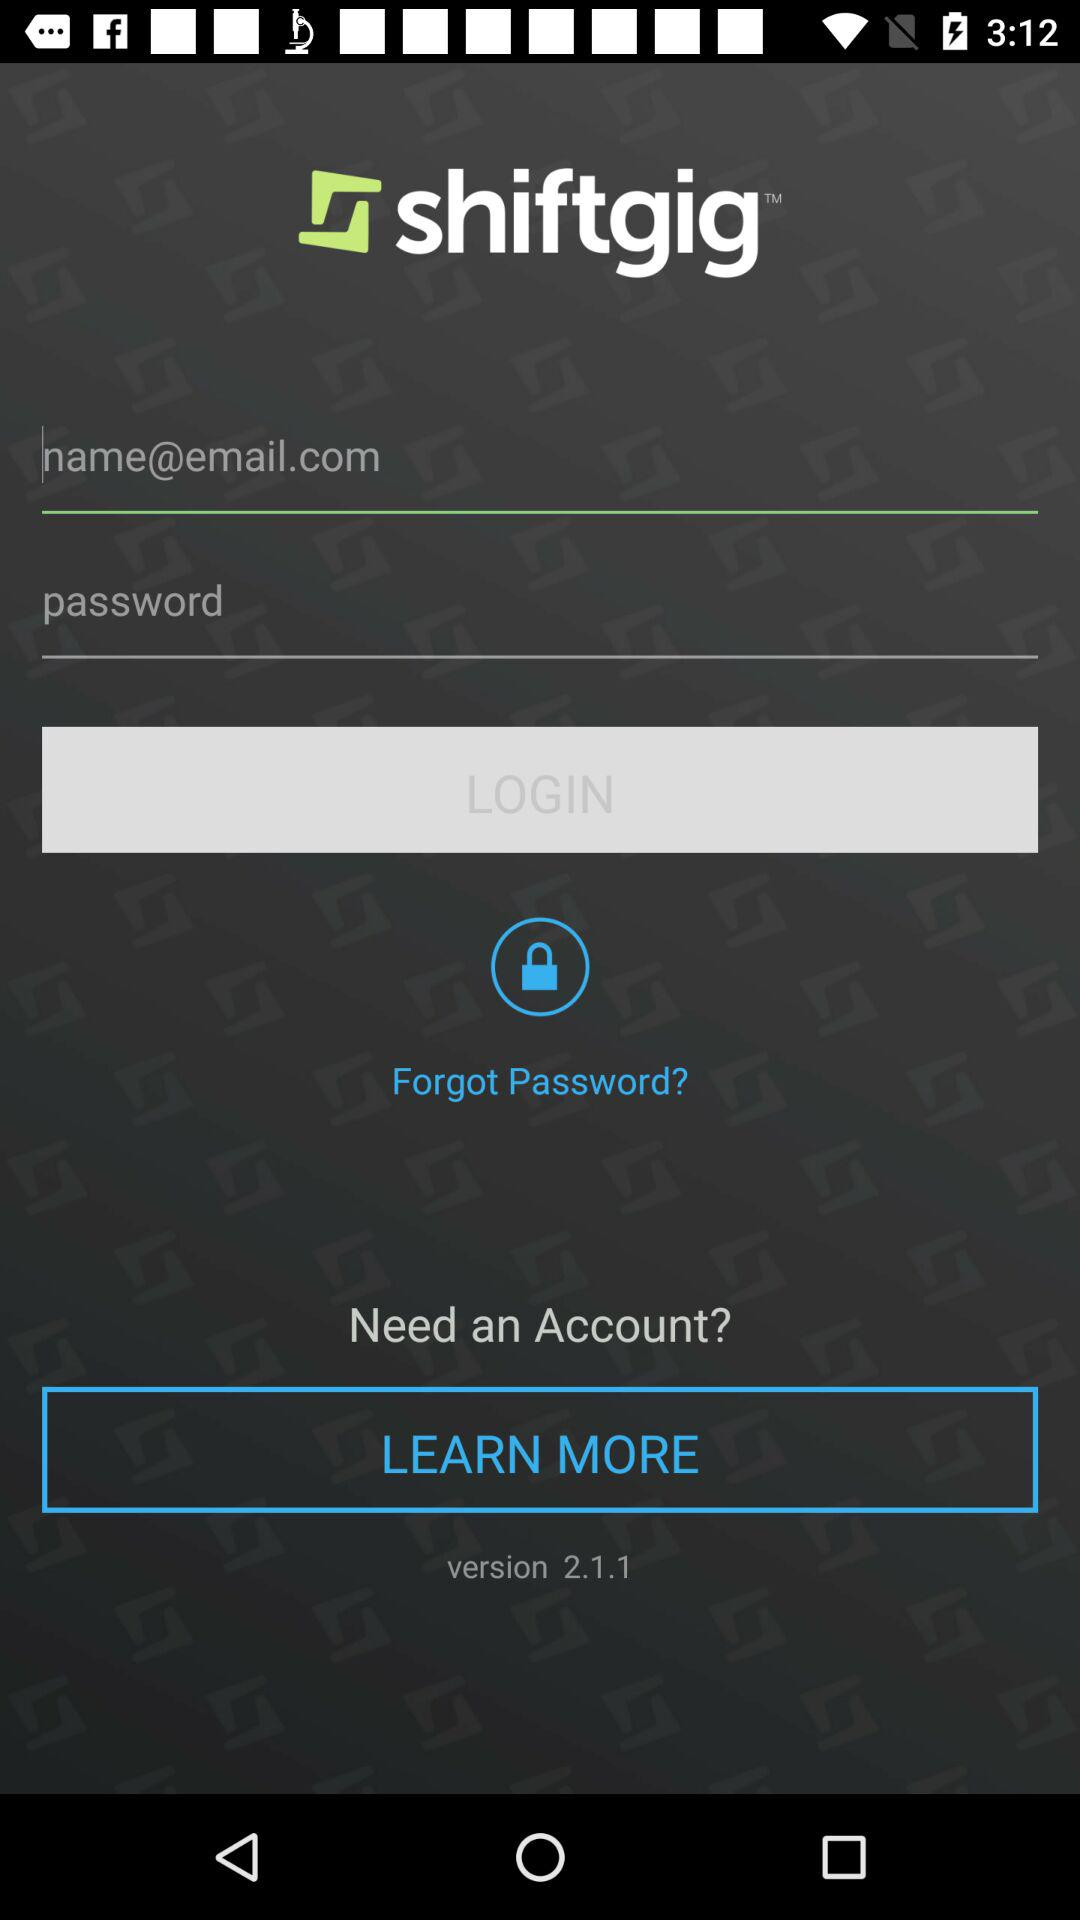How many text fields are there on this screen?
Answer the question using a single word or phrase. 2 